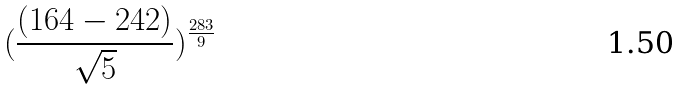Convert formula to latex. <formula><loc_0><loc_0><loc_500><loc_500>( \frac { ( 1 6 4 - 2 4 2 ) } { \sqrt { 5 } } ) ^ { \frac { 2 8 3 } { 9 } }</formula> 